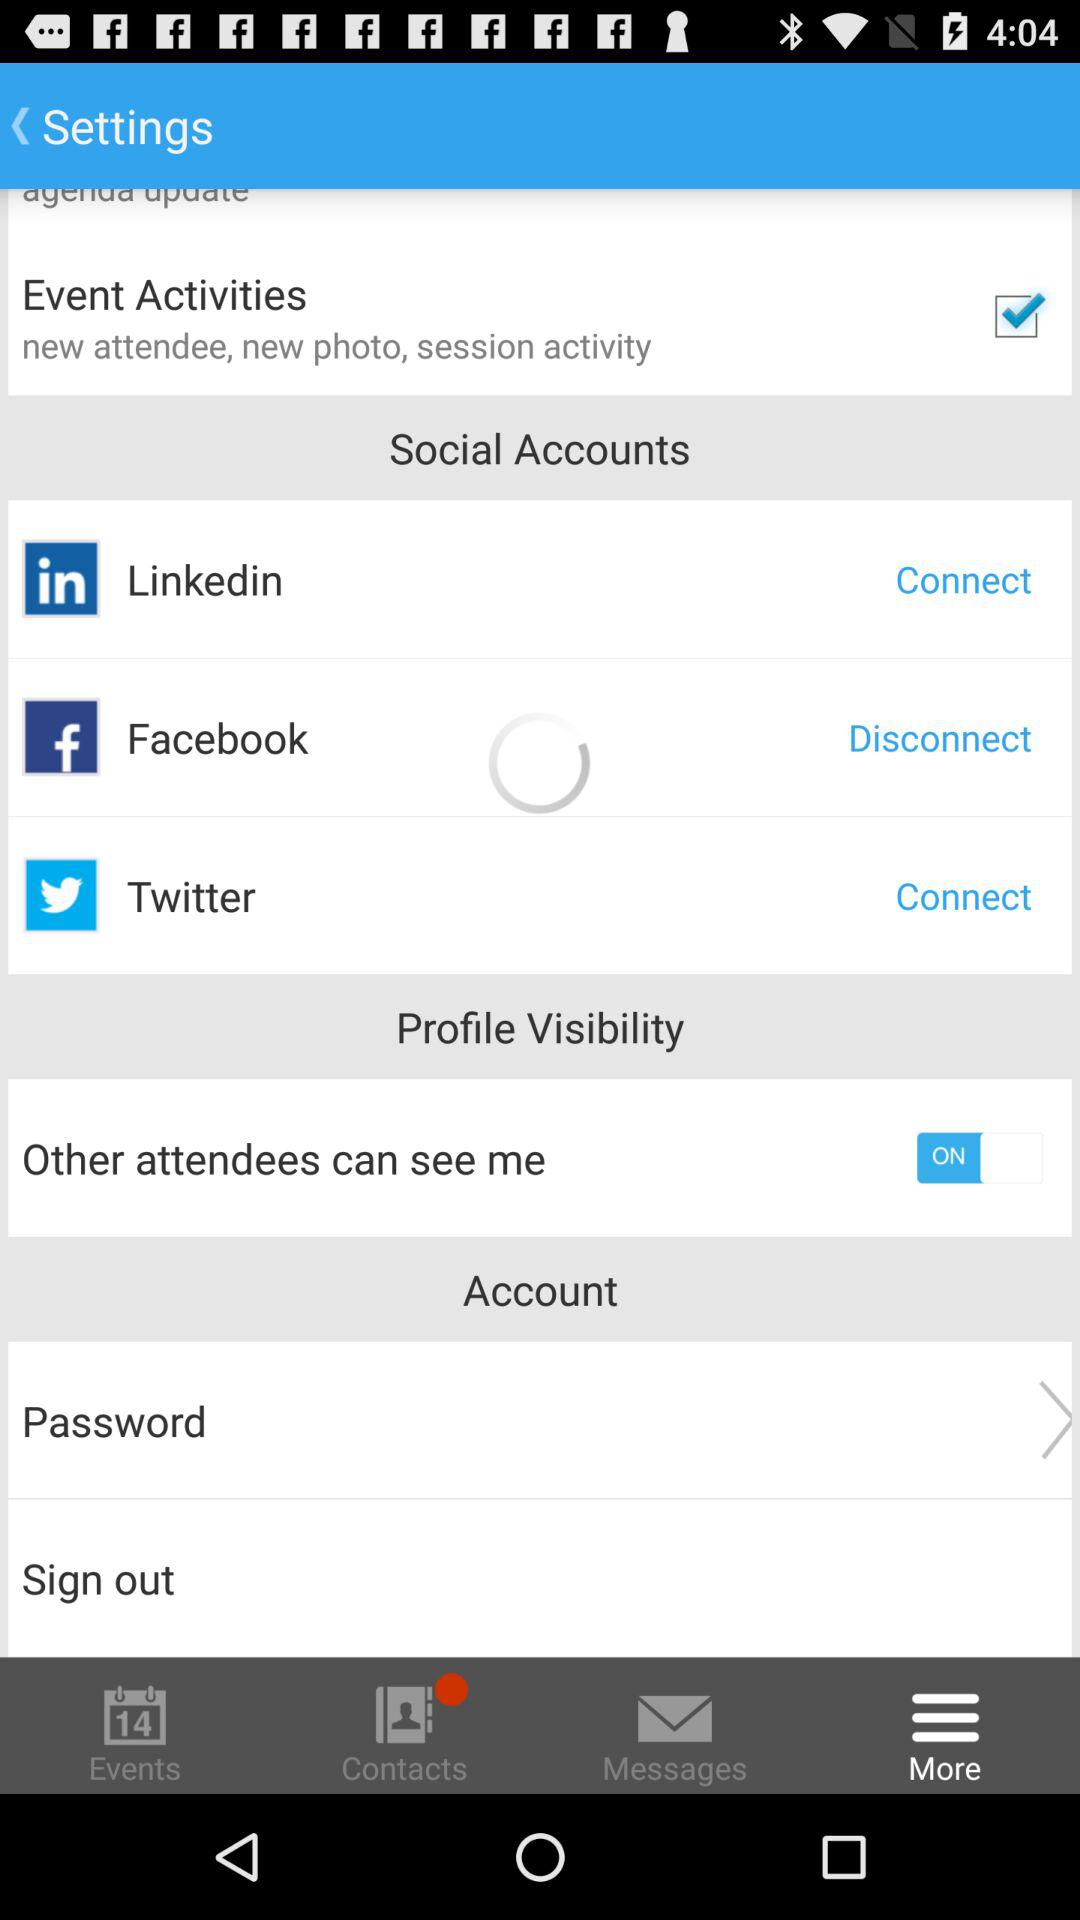What is the status of "Other attendees can see me"? The status is "on". 